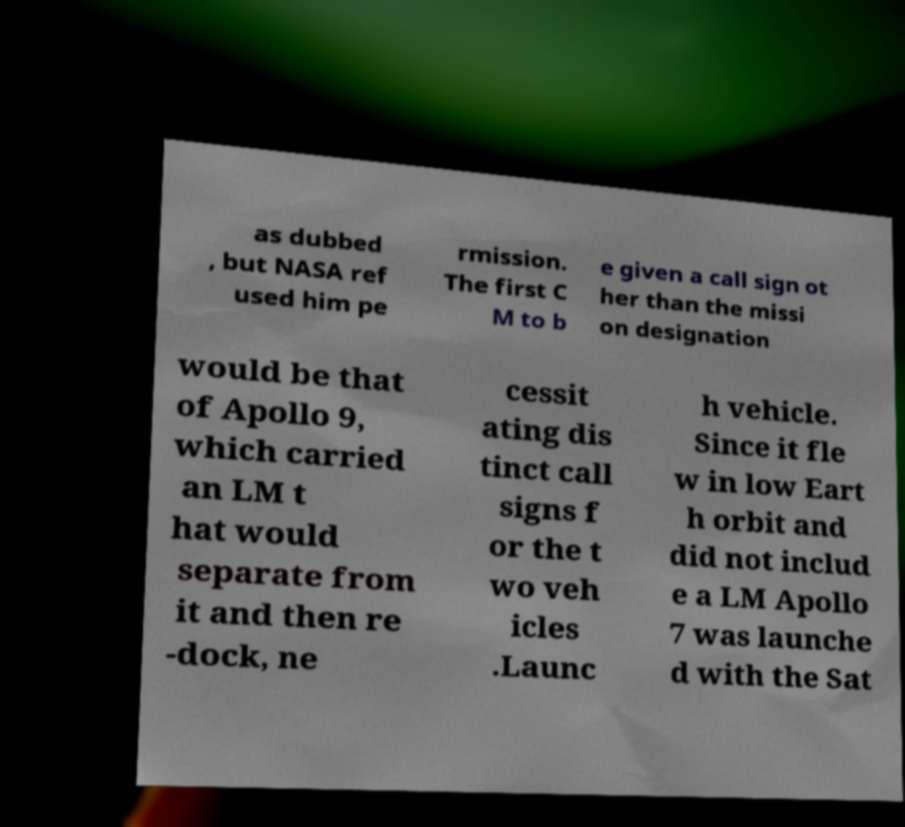I need the written content from this picture converted into text. Can you do that? as dubbed , but NASA ref used him pe rmission. The first C M to b e given a call sign ot her than the missi on designation would be that of Apollo 9, which carried an LM t hat would separate from it and then re -dock, ne cessit ating dis tinct call signs f or the t wo veh icles .Launc h vehicle. Since it fle w in low Eart h orbit and did not includ e a LM Apollo 7 was launche d with the Sat 